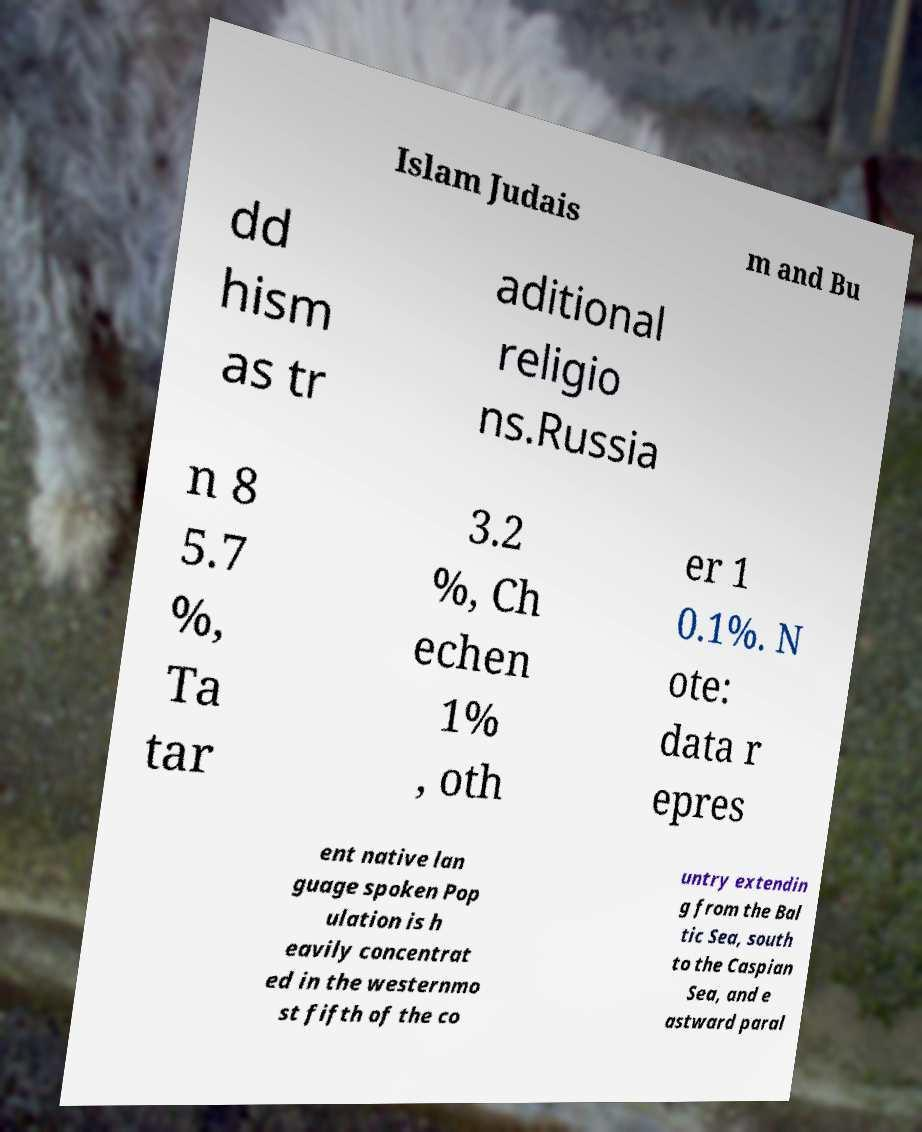There's text embedded in this image that I need extracted. Can you transcribe it verbatim? Islam Judais m and Bu dd hism as tr aditional religio ns.Russia n 8 5.7 %, Ta tar 3.2 %, Ch echen 1% , oth er 1 0.1%. N ote: data r epres ent native lan guage spoken Pop ulation is h eavily concentrat ed in the westernmo st fifth of the co untry extendin g from the Bal tic Sea, south to the Caspian Sea, and e astward paral 